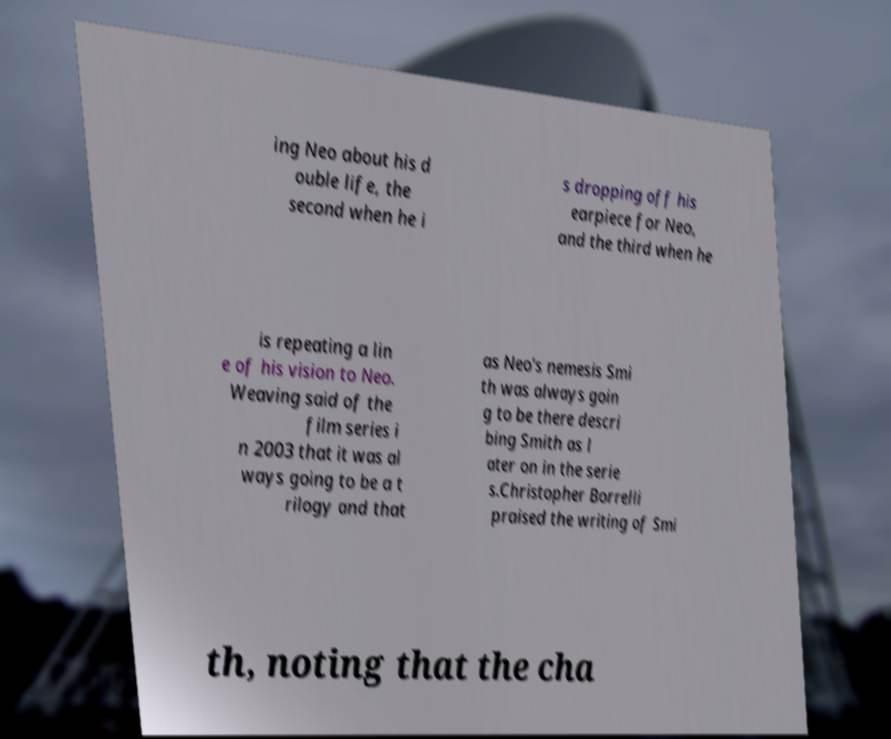For documentation purposes, I need the text within this image transcribed. Could you provide that? ing Neo about his d ouble life, the second when he i s dropping off his earpiece for Neo, and the third when he is repeating a lin e of his vision to Neo. Weaving said of the film series i n 2003 that it was al ways going to be a t rilogy and that as Neo's nemesis Smi th was always goin g to be there descri bing Smith as l ater on in the serie s.Christopher Borrelli praised the writing of Smi th, noting that the cha 